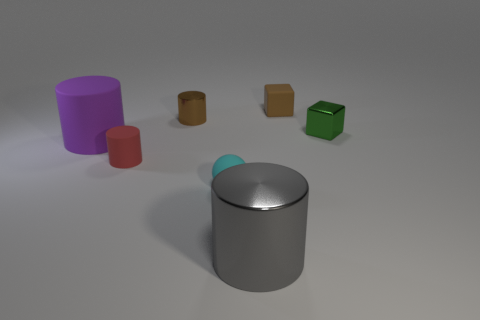Is the number of brown shiny cylinders greater than the number of small metallic balls?
Offer a terse response. Yes. How many other things are the same material as the big gray cylinder?
Your answer should be compact. 2. What is the shape of the tiny metal thing that is behind the shiny thing right of the tiny matte object that is behind the big rubber cylinder?
Give a very brief answer. Cylinder. Are there fewer rubber cylinders in front of the tiny cyan rubber ball than things in front of the large purple rubber cylinder?
Offer a terse response. Yes. Is there a small thing that has the same color as the matte block?
Your answer should be compact. Yes. Do the cyan ball and the small red cylinder on the right side of the purple cylinder have the same material?
Make the answer very short. Yes. There is a gray metallic cylinder that is in front of the small green object; is there a cylinder behind it?
Provide a succinct answer. Yes. There is a tiny rubber object that is in front of the tiny brown rubber object and behind the small cyan thing; what is its color?
Provide a succinct answer. Red. What is the size of the purple cylinder?
Your answer should be compact. Large. How many red things are the same size as the rubber block?
Offer a very short reply. 1. 